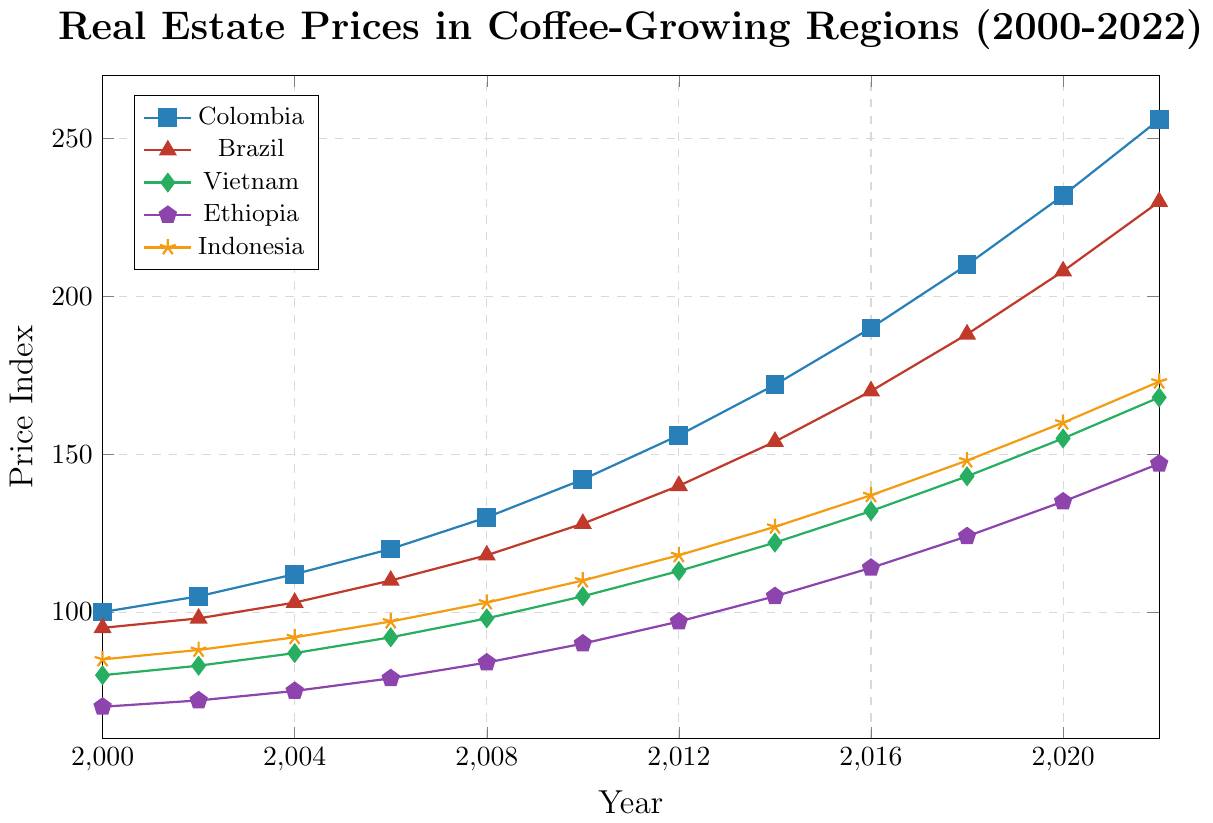what trend can be observed in real estate prices in Ethiopia from 2000 to 2022? From 2000 to 2022, the real estate prices in Ethiopia consistently increased each year, demonstrating a rising trend. Starting at 70 in 2000, the prices increased steadily through the years, reaching 147 in 2022.
Answer: Consistently increasing trend Which region had the highest price index in 2022? To answer this, we look at the price indices for each region in 2022 and compare them. Colombia has a price index of 256, Brazil has 230, Vietnam has 168, Ethiopia has 147, and Indonesia has 173. The highest value among these is 256 for Colombia.
Answer: Colombia What is the difference in the price index of Brazil between 2008 and 2018? To find the difference, subtract Brazil’s price index in 2008 (118) from its price index in 2018 (188): 188 - 118 = 70.
Answer: 70 What are the average prices of real estate in Vietnam from 2000 to 2022? To find the average, sum all the price indices for Vietnam from 2000 to 2022 and then divide by the number of data points. (80 + 83 + 87 + 92 + 98 + 105 + 113 + 122 + 132 + 143 + 155 + 168) / 12 = 1148 / 12 = 95.67.
Answer: 95.67 How do the trends of real estate prices in Ethiopia and Indonesia compare from 2000 to 2022? Both countries show a consistently increasing trend in real estate prices from 2000 to 2022. Ethiopia’s price index rose from 70 to 147, while Indonesia’s price index rose from 85 to 173 over the same period. However, Indonesia's prices increased at a slightly higher rate.
Answer: Both increasing; Indonesia at a higher rate Which year saw the highest jump in real estate prices for Colombia? Comparing the price indices year-over-year for Colombia: the jumps are as follows: 5 (2000 to 2002), 7 (2002 to 2004), 8 (2004 to 2006), 10 (2006 to 2008), 12 (2008 to 2010), 14 (2010 to 2012), 16 (2012 to 2014), 18 (2014 to 2016), 20 (2016 to 2018), 22 (2018 to 2020), 24 (2020 to 2022). The highest jump occurred between 2020 and 2022 with a jump of 24.
Answer: 2020 to 2022 Which region had the lowest price index in 2010, and what was the value? To determine the lowest price index in 2010, compare the price indices for each region: Colombia (142), Brazil (128), Vietnam (105), Ethiopia (90), and Indonesia (110). The lowest value among these is 90 for Ethiopia.
Answer: Ethiopia, 90 How much did the real estate prices in Vietnam grow from 2000 to 2022? To find how much they grew, subtract the price index in 2000 (80) from the price index in 2022 (168): 168 - 80 = 88.
Answer: 88 Which region's real estate prices had the smallest increase from 2000 to 2022? Calculate the difference between the 2000 and 2022 values for each region: Colombia (256 - 100 = 156), Brazil (230 - 95 = 135), Vietnam (168 - 80 = 88), Ethiopia (147 - 70 = 77), Indonesia (173 - 85 = 88). Ethiopia had the smallest increase of 77.
Answer: Ethiopia 